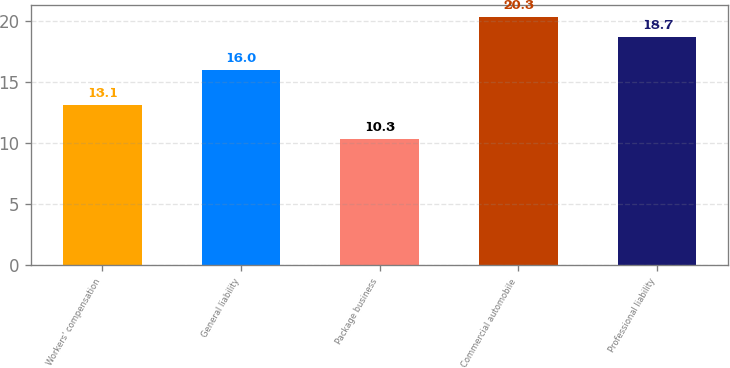Convert chart. <chart><loc_0><loc_0><loc_500><loc_500><bar_chart><fcel>Workers' compensation<fcel>General liability<fcel>Package business<fcel>Commercial automobile<fcel>Professional liability<nl><fcel>13.1<fcel>16<fcel>10.3<fcel>20.3<fcel>18.7<nl></chart> 